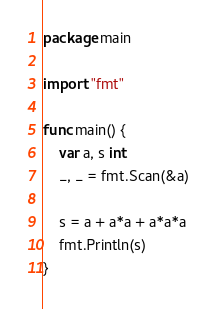<code> <loc_0><loc_0><loc_500><loc_500><_Go_>package main

import "fmt"

func main() {
	var a, s int
	_, _ = fmt.Scan(&a)

	s = a + a*a + a*a*a
	fmt.Println(s)
}
</code> 